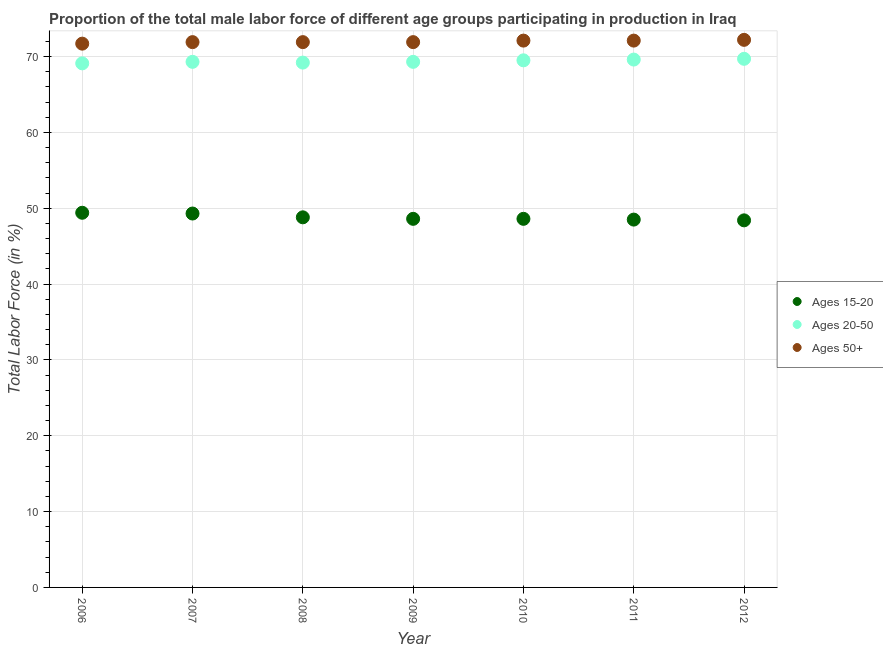How many different coloured dotlines are there?
Ensure brevity in your answer.  3. Is the number of dotlines equal to the number of legend labels?
Offer a terse response. Yes. What is the percentage of male labor force within the age group 15-20 in 2010?
Keep it short and to the point. 48.6. Across all years, what is the maximum percentage of male labor force within the age group 20-50?
Ensure brevity in your answer.  69.7. Across all years, what is the minimum percentage of male labor force above age 50?
Offer a terse response. 71.7. In which year was the percentage of male labor force above age 50 maximum?
Ensure brevity in your answer.  2012. In which year was the percentage of male labor force within the age group 20-50 minimum?
Keep it short and to the point. 2006. What is the total percentage of male labor force above age 50 in the graph?
Give a very brief answer. 503.8. What is the difference between the percentage of male labor force above age 50 in 2007 and that in 2008?
Your answer should be compact. 0. What is the difference between the percentage of male labor force within the age group 20-50 in 2007 and the percentage of male labor force within the age group 15-20 in 2012?
Offer a very short reply. 20.9. What is the average percentage of male labor force above age 50 per year?
Give a very brief answer. 71.97. In the year 2012, what is the difference between the percentage of male labor force within the age group 20-50 and percentage of male labor force within the age group 15-20?
Your answer should be compact. 21.3. What is the ratio of the percentage of male labor force within the age group 20-50 in 2007 to that in 2012?
Give a very brief answer. 0.99. What is the difference between the highest and the second highest percentage of male labor force within the age group 15-20?
Offer a very short reply. 0.1. What is the difference between the highest and the lowest percentage of male labor force within the age group 20-50?
Provide a short and direct response. 0.6. In how many years, is the percentage of male labor force within the age group 20-50 greater than the average percentage of male labor force within the age group 20-50 taken over all years?
Your response must be concise. 3. Is the sum of the percentage of male labor force within the age group 20-50 in 2006 and 2012 greater than the maximum percentage of male labor force within the age group 15-20 across all years?
Provide a short and direct response. Yes. Is it the case that in every year, the sum of the percentage of male labor force within the age group 15-20 and percentage of male labor force within the age group 20-50 is greater than the percentage of male labor force above age 50?
Provide a succinct answer. Yes. Does the percentage of male labor force above age 50 monotonically increase over the years?
Offer a terse response. No. Is the percentage of male labor force above age 50 strictly greater than the percentage of male labor force within the age group 20-50 over the years?
Ensure brevity in your answer.  Yes. How many years are there in the graph?
Ensure brevity in your answer.  7. What is the difference between two consecutive major ticks on the Y-axis?
Your answer should be compact. 10. Are the values on the major ticks of Y-axis written in scientific E-notation?
Your response must be concise. No. Does the graph contain any zero values?
Your response must be concise. No. Does the graph contain grids?
Provide a succinct answer. Yes. What is the title of the graph?
Keep it short and to the point. Proportion of the total male labor force of different age groups participating in production in Iraq. Does "Ages 15-20" appear as one of the legend labels in the graph?
Your answer should be very brief. Yes. What is the label or title of the X-axis?
Keep it short and to the point. Year. What is the label or title of the Y-axis?
Give a very brief answer. Total Labor Force (in %). What is the Total Labor Force (in %) of Ages 15-20 in 2006?
Keep it short and to the point. 49.4. What is the Total Labor Force (in %) of Ages 20-50 in 2006?
Offer a terse response. 69.1. What is the Total Labor Force (in %) of Ages 50+ in 2006?
Ensure brevity in your answer.  71.7. What is the Total Labor Force (in %) of Ages 15-20 in 2007?
Provide a succinct answer. 49.3. What is the Total Labor Force (in %) of Ages 20-50 in 2007?
Offer a very short reply. 69.3. What is the Total Labor Force (in %) of Ages 50+ in 2007?
Give a very brief answer. 71.9. What is the Total Labor Force (in %) in Ages 15-20 in 2008?
Provide a short and direct response. 48.8. What is the Total Labor Force (in %) in Ages 20-50 in 2008?
Your response must be concise. 69.2. What is the Total Labor Force (in %) of Ages 50+ in 2008?
Give a very brief answer. 71.9. What is the Total Labor Force (in %) in Ages 15-20 in 2009?
Give a very brief answer. 48.6. What is the Total Labor Force (in %) in Ages 20-50 in 2009?
Provide a short and direct response. 69.3. What is the Total Labor Force (in %) of Ages 50+ in 2009?
Ensure brevity in your answer.  71.9. What is the Total Labor Force (in %) in Ages 15-20 in 2010?
Your answer should be very brief. 48.6. What is the Total Labor Force (in %) of Ages 20-50 in 2010?
Provide a short and direct response. 69.5. What is the Total Labor Force (in %) in Ages 50+ in 2010?
Keep it short and to the point. 72.1. What is the Total Labor Force (in %) of Ages 15-20 in 2011?
Your answer should be compact. 48.5. What is the Total Labor Force (in %) in Ages 20-50 in 2011?
Make the answer very short. 69.6. What is the Total Labor Force (in %) in Ages 50+ in 2011?
Ensure brevity in your answer.  72.1. What is the Total Labor Force (in %) of Ages 15-20 in 2012?
Ensure brevity in your answer.  48.4. What is the Total Labor Force (in %) in Ages 20-50 in 2012?
Provide a succinct answer. 69.7. What is the Total Labor Force (in %) in Ages 50+ in 2012?
Your answer should be compact. 72.2. Across all years, what is the maximum Total Labor Force (in %) in Ages 15-20?
Offer a very short reply. 49.4. Across all years, what is the maximum Total Labor Force (in %) in Ages 20-50?
Give a very brief answer. 69.7. Across all years, what is the maximum Total Labor Force (in %) in Ages 50+?
Offer a very short reply. 72.2. Across all years, what is the minimum Total Labor Force (in %) in Ages 15-20?
Ensure brevity in your answer.  48.4. Across all years, what is the minimum Total Labor Force (in %) of Ages 20-50?
Offer a terse response. 69.1. Across all years, what is the minimum Total Labor Force (in %) in Ages 50+?
Your answer should be very brief. 71.7. What is the total Total Labor Force (in %) in Ages 15-20 in the graph?
Your answer should be very brief. 341.6. What is the total Total Labor Force (in %) in Ages 20-50 in the graph?
Provide a succinct answer. 485.7. What is the total Total Labor Force (in %) of Ages 50+ in the graph?
Your response must be concise. 503.8. What is the difference between the Total Labor Force (in %) of Ages 15-20 in 2006 and that in 2007?
Ensure brevity in your answer.  0.1. What is the difference between the Total Labor Force (in %) of Ages 20-50 in 2006 and that in 2007?
Keep it short and to the point. -0.2. What is the difference between the Total Labor Force (in %) in Ages 15-20 in 2006 and that in 2008?
Keep it short and to the point. 0.6. What is the difference between the Total Labor Force (in %) of Ages 20-50 in 2006 and that in 2008?
Offer a very short reply. -0.1. What is the difference between the Total Labor Force (in %) in Ages 50+ in 2006 and that in 2008?
Your answer should be very brief. -0.2. What is the difference between the Total Labor Force (in %) in Ages 15-20 in 2006 and that in 2010?
Keep it short and to the point. 0.8. What is the difference between the Total Labor Force (in %) in Ages 20-50 in 2006 and that in 2010?
Give a very brief answer. -0.4. What is the difference between the Total Labor Force (in %) of Ages 50+ in 2006 and that in 2012?
Keep it short and to the point. -0.5. What is the difference between the Total Labor Force (in %) in Ages 15-20 in 2007 and that in 2008?
Offer a very short reply. 0.5. What is the difference between the Total Labor Force (in %) in Ages 20-50 in 2007 and that in 2008?
Your answer should be compact. 0.1. What is the difference between the Total Labor Force (in %) of Ages 15-20 in 2007 and that in 2009?
Your response must be concise. 0.7. What is the difference between the Total Labor Force (in %) of Ages 20-50 in 2007 and that in 2009?
Offer a very short reply. 0. What is the difference between the Total Labor Force (in %) in Ages 50+ in 2007 and that in 2009?
Your response must be concise. 0. What is the difference between the Total Labor Force (in %) in Ages 50+ in 2007 and that in 2010?
Keep it short and to the point. -0.2. What is the difference between the Total Labor Force (in %) in Ages 15-20 in 2007 and that in 2011?
Make the answer very short. 0.8. What is the difference between the Total Labor Force (in %) of Ages 15-20 in 2007 and that in 2012?
Your response must be concise. 0.9. What is the difference between the Total Labor Force (in %) in Ages 50+ in 2007 and that in 2012?
Provide a short and direct response. -0.3. What is the difference between the Total Labor Force (in %) of Ages 15-20 in 2008 and that in 2009?
Your response must be concise. 0.2. What is the difference between the Total Labor Force (in %) of Ages 20-50 in 2008 and that in 2009?
Provide a succinct answer. -0.1. What is the difference between the Total Labor Force (in %) in Ages 20-50 in 2008 and that in 2010?
Make the answer very short. -0.3. What is the difference between the Total Labor Force (in %) of Ages 50+ in 2008 and that in 2010?
Offer a very short reply. -0.2. What is the difference between the Total Labor Force (in %) of Ages 15-20 in 2008 and that in 2011?
Ensure brevity in your answer.  0.3. What is the difference between the Total Labor Force (in %) of Ages 20-50 in 2008 and that in 2011?
Offer a very short reply. -0.4. What is the difference between the Total Labor Force (in %) in Ages 50+ in 2008 and that in 2011?
Offer a terse response. -0.2. What is the difference between the Total Labor Force (in %) in Ages 15-20 in 2008 and that in 2012?
Provide a short and direct response. 0.4. What is the difference between the Total Labor Force (in %) in Ages 20-50 in 2008 and that in 2012?
Your answer should be compact. -0.5. What is the difference between the Total Labor Force (in %) in Ages 15-20 in 2009 and that in 2011?
Your response must be concise. 0.1. What is the difference between the Total Labor Force (in %) of Ages 50+ in 2009 and that in 2011?
Make the answer very short. -0.2. What is the difference between the Total Labor Force (in %) of Ages 15-20 in 2009 and that in 2012?
Give a very brief answer. 0.2. What is the difference between the Total Labor Force (in %) in Ages 20-50 in 2009 and that in 2012?
Provide a short and direct response. -0.4. What is the difference between the Total Labor Force (in %) in Ages 50+ in 2010 and that in 2011?
Ensure brevity in your answer.  0. What is the difference between the Total Labor Force (in %) of Ages 20-50 in 2010 and that in 2012?
Keep it short and to the point. -0.2. What is the difference between the Total Labor Force (in %) of Ages 50+ in 2010 and that in 2012?
Provide a succinct answer. -0.1. What is the difference between the Total Labor Force (in %) in Ages 50+ in 2011 and that in 2012?
Make the answer very short. -0.1. What is the difference between the Total Labor Force (in %) in Ages 15-20 in 2006 and the Total Labor Force (in %) in Ages 20-50 in 2007?
Ensure brevity in your answer.  -19.9. What is the difference between the Total Labor Force (in %) in Ages 15-20 in 2006 and the Total Labor Force (in %) in Ages 50+ in 2007?
Ensure brevity in your answer.  -22.5. What is the difference between the Total Labor Force (in %) in Ages 20-50 in 2006 and the Total Labor Force (in %) in Ages 50+ in 2007?
Provide a succinct answer. -2.8. What is the difference between the Total Labor Force (in %) in Ages 15-20 in 2006 and the Total Labor Force (in %) in Ages 20-50 in 2008?
Your answer should be compact. -19.8. What is the difference between the Total Labor Force (in %) in Ages 15-20 in 2006 and the Total Labor Force (in %) in Ages 50+ in 2008?
Give a very brief answer. -22.5. What is the difference between the Total Labor Force (in %) of Ages 15-20 in 2006 and the Total Labor Force (in %) of Ages 20-50 in 2009?
Keep it short and to the point. -19.9. What is the difference between the Total Labor Force (in %) in Ages 15-20 in 2006 and the Total Labor Force (in %) in Ages 50+ in 2009?
Give a very brief answer. -22.5. What is the difference between the Total Labor Force (in %) of Ages 20-50 in 2006 and the Total Labor Force (in %) of Ages 50+ in 2009?
Your answer should be compact. -2.8. What is the difference between the Total Labor Force (in %) of Ages 15-20 in 2006 and the Total Labor Force (in %) of Ages 20-50 in 2010?
Provide a short and direct response. -20.1. What is the difference between the Total Labor Force (in %) of Ages 15-20 in 2006 and the Total Labor Force (in %) of Ages 50+ in 2010?
Provide a short and direct response. -22.7. What is the difference between the Total Labor Force (in %) of Ages 20-50 in 2006 and the Total Labor Force (in %) of Ages 50+ in 2010?
Provide a succinct answer. -3. What is the difference between the Total Labor Force (in %) of Ages 15-20 in 2006 and the Total Labor Force (in %) of Ages 20-50 in 2011?
Offer a very short reply. -20.2. What is the difference between the Total Labor Force (in %) of Ages 15-20 in 2006 and the Total Labor Force (in %) of Ages 50+ in 2011?
Ensure brevity in your answer.  -22.7. What is the difference between the Total Labor Force (in %) in Ages 15-20 in 2006 and the Total Labor Force (in %) in Ages 20-50 in 2012?
Your answer should be compact. -20.3. What is the difference between the Total Labor Force (in %) of Ages 15-20 in 2006 and the Total Labor Force (in %) of Ages 50+ in 2012?
Ensure brevity in your answer.  -22.8. What is the difference between the Total Labor Force (in %) of Ages 20-50 in 2006 and the Total Labor Force (in %) of Ages 50+ in 2012?
Offer a very short reply. -3.1. What is the difference between the Total Labor Force (in %) in Ages 15-20 in 2007 and the Total Labor Force (in %) in Ages 20-50 in 2008?
Offer a terse response. -19.9. What is the difference between the Total Labor Force (in %) of Ages 15-20 in 2007 and the Total Labor Force (in %) of Ages 50+ in 2008?
Ensure brevity in your answer.  -22.6. What is the difference between the Total Labor Force (in %) of Ages 20-50 in 2007 and the Total Labor Force (in %) of Ages 50+ in 2008?
Your answer should be very brief. -2.6. What is the difference between the Total Labor Force (in %) of Ages 15-20 in 2007 and the Total Labor Force (in %) of Ages 20-50 in 2009?
Your answer should be compact. -20. What is the difference between the Total Labor Force (in %) of Ages 15-20 in 2007 and the Total Labor Force (in %) of Ages 50+ in 2009?
Provide a succinct answer. -22.6. What is the difference between the Total Labor Force (in %) in Ages 15-20 in 2007 and the Total Labor Force (in %) in Ages 20-50 in 2010?
Ensure brevity in your answer.  -20.2. What is the difference between the Total Labor Force (in %) in Ages 15-20 in 2007 and the Total Labor Force (in %) in Ages 50+ in 2010?
Offer a very short reply. -22.8. What is the difference between the Total Labor Force (in %) of Ages 15-20 in 2007 and the Total Labor Force (in %) of Ages 20-50 in 2011?
Keep it short and to the point. -20.3. What is the difference between the Total Labor Force (in %) in Ages 15-20 in 2007 and the Total Labor Force (in %) in Ages 50+ in 2011?
Offer a terse response. -22.8. What is the difference between the Total Labor Force (in %) in Ages 15-20 in 2007 and the Total Labor Force (in %) in Ages 20-50 in 2012?
Offer a very short reply. -20.4. What is the difference between the Total Labor Force (in %) of Ages 15-20 in 2007 and the Total Labor Force (in %) of Ages 50+ in 2012?
Make the answer very short. -22.9. What is the difference between the Total Labor Force (in %) of Ages 15-20 in 2008 and the Total Labor Force (in %) of Ages 20-50 in 2009?
Your answer should be very brief. -20.5. What is the difference between the Total Labor Force (in %) in Ages 15-20 in 2008 and the Total Labor Force (in %) in Ages 50+ in 2009?
Your answer should be very brief. -23.1. What is the difference between the Total Labor Force (in %) in Ages 20-50 in 2008 and the Total Labor Force (in %) in Ages 50+ in 2009?
Offer a very short reply. -2.7. What is the difference between the Total Labor Force (in %) of Ages 15-20 in 2008 and the Total Labor Force (in %) of Ages 20-50 in 2010?
Ensure brevity in your answer.  -20.7. What is the difference between the Total Labor Force (in %) of Ages 15-20 in 2008 and the Total Labor Force (in %) of Ages 50+ in 2010?
Your answer should be compact. -23.3. What is the difference between the Total Labor Force (in %) of Ages 15-20 in 2008 and the Total Labor Force (in %) of Ages 20-50 in 2011?
Offer a very short reply. -20.8. What is the difference between the Total Labor Force (in %) of Ages 15-20 in 2008 and the Total Labor Force (in %) of Ages 50+ in 2011?
Offer a terse response. -23.3. What is the difference between the Total Labor Force (in %) in Ages 20-50 in 2008 and the Total Labor Force (in %) in Ages 50+ in 2011?
Your response must be concise. -2.9. What is the difference between the Total Labor Force (in %) of Ages 15-20 in 2008 and the Total Labor Force (in %) of Ages 20-50 in 2012?
Your response must be concise. -20.9. What is the difference between the Total Labor Force (in %) in Ages 15-20 in 2008 and the Total Labor Force (in %) in Ages 50+ in 2012?
Your response must be concise. -23.4. What is the difference between the Total Labor Force (in %) of Ages 15-20 in 2009 and the Total Labor Force (in %) of Ages 20-50 in 2010?
Ensure brevity in your answer.  -20.9. What is the difference between the Total Labor Force (in %) of Ages 15-20 in 2009 and the Total Labor Force (in %) of Ages 50+ in 2010?
Your answer should be compact. -23.5. What is the difference between the Total Labor Force (in %) in Ages 15-20 in 2009 and the Total Labor Force (in %) in Ages 20-50 in 2011?
Give a very brief answer. -21. What is the difference between the Total Labor Force (in %) of Ages 15-20 in 2009 and the Total Labor Force (in %) of Ages 50+ in 2011?
Keep it short and to the point. -23.5. What is the difference between the Total Labor Force (in %) of Ages 20-50 in 2009 and the Total Labor Force (in %) of Ages 50+ in 2011?
Keep it short and to the point. -2.8. What is the difference between the Total Labor Force (in %) of Ages 15-20 in 2009 and the Total Labor Force (in %) of Ages 20-50 in 2012?
Your answer should be very brief. -21.1. What is the difference between the Total Labor Force (in %) of Ages 15-20 in 2009 and the Total Labor Force (in %) of Ages 50+ in 2012?
Your response must be concise. -23.6. What is the difference between the Total Labor Force (in %) of Ages 15-20 in 2010 and the Total Labor Force (in %) of Ages 20-50 in 2011?
Provide a short and direct response. -21. What is the difference between the Total Labor Force (in %) in Ages 15-20 in 2010 and the Total Labor Force (in %) in Ages 50+ in 2011?
Your response must be concise. -23.5. What is the difference between the Total Labor Force (in %) in Ages 20-50 in 2010 and the Total Labor Force (in %) in Ages 50+ in 2011?
Provide a succinct answer. -2.6. What is the difference between the Total Labor Force (in %) of Ages 15-20 in 2010 and the Total Labor Force (in %) of Ages 20-50 in 2012?
Provide a short and direct response. -21.1. What is the difference between the Total Labor Force (in %) in Ages 15-20 in 2010 and the Total Labor Force (in %) in Ages 50+ in 2012?
Your answer should be very brief. -23.6. What is the difference between the Total Labor Force (in %) in Ages 15-20 in 2011 and the Total Labor Force (in %) in Ages 20-50 in 2012?
Offer a very short reply. -21.2. What is the difference between the Total Labor Force (in %) in Ages 15-20 in 2011 and the Total Labor Force (in %) in Ages 50+ in 2012?
Your response must be concise. -23.7. What is the difference between the Total Labor Force (in %) of Ages 20-50 in 2011 and the Total Labor Force (in %) of Ages 50+ in 2012?
Make the answer very short. -2.6. What is the average Total Labor Force (in %) in Ages 15-20 per year?
Your answer should be very brief. 48.8. What is the average Total Labor Force (in %) in Ages 20-50 per year?
Keep it short and to the point. 69.39. What is the average Total Labor Force (in %) in Ages 50+ per year?
Provide a succinct answer. 71.97. In the year 2006, what is the difference between the Total Labor Force (in %) of Ages 15-20 and Total Labor Force (in %) of Ages 20-50?
Your answer should be very brief. -19.7. In the year 2006, what is the difference between the Total Labor Force (in %) in Ages 15-20 and Total Labor Force (in %) in Ages 50+?
Provide a short and direct response. -22.3. In the year 2006, what is the difference between the Total Labor Force (in %) in Ages 20-50 and Total Labor Force (in %) in Ages 50+?
Your response must be concise. -2.6. In the year 2007, what is the difference between the Total Labor Force (in %) of Ages 15-20 and Total Labor Force (in %) of Ages 50+?
Ensure brevity in your answer.  -22.6. In the year 2008, what is the difference between the Total Labor Force (in %) of Ages 15-20 and Total Labor Force (in %) of Ages 20-50?
Your response must be concise. -20.4. In the year 2008, what is the difference between the Total Labor Force (in %) in Ages 15-20 and Total Labor Force (in %) in Ages 50+?
Keep it short and to the point. -23.1. In the year 2008, what is the difference between the Total Labor Force (in %) of Ages 20-50 and Total Labor Force (in %) of Ages 50+?
Make the answer very short. -2.7. In the year 2009, what is the difference between the Total Labor Force (in %) of Ages 15-20 and Total Labor Force (in %) of Ages 20-50?
Provide a succinct answer. -20.7. In the year 2009, what is the difference between the Total Labor Force (in %) in Ages 15-20 and Total Labor Force (in %) in Ages 50+?
Give a very brief answer. -23.3. In the year 2010, what is the difference between the Total Labor Force (in %) in Ages 15-20 and Total Labor Force (in %) in Ages 20-50?
Provide a short and direct response. -20.9. In the year 2010, what is the difference between the Total Labor Force (in %) of Ages 15-20 and Total Labor Force (in %) of Ages 50+?
Make the answer very short. -23.5. In the year 2011, what is the difference between the Total Labor Force (in %) of Ages 15-20 and Total Labor Force (in %) of Ages 20-50?
Offer a terse response. -21.1. In the year 2011, what is the difference between the Total Labor Force (in %) of Ages 15-20 and Total Labor Force (in %) of Ages 50+?
Provide a short and direct response. -23.6. In the year 2012, what is the difference between the Total Labor Force (in %) in Ages 15-20 and Total Labor Force (in %) in Ages 20-50?
Offer a terse response. -21.3. In the year 2012, what is the difference between the Total Labor Force (in %) in Ages 15-20 and Total Labor Force (in %) in Ages 50+?
Your response must be concise. -23.8. In the year 2012, what is the difference between the Total Labor Force (in %) of Ages 20-50 and Total Labor Force (in %) of Ages 50+?
Ensure brevity in your answer.  -2.5. What is the ratio of the Total Labor Force (in %) of Ages 50+ in 2006 to that in 2007?
Your answer should be compact. 1. What is the ratio of the Total Labor Force (in %) of Ages 15-20 in 2006 to that in 2008?
Offer a terse response. 1.01. What is the ratio of the Total Labor Force (in %) in Ages 15-20 in 2006 to that in 2009?
Provide a short and direct response. 1.02. What is the ratio of the Total Labor Force (in %) in Ages 15-20 in 2006 to that in 2010?
Provide a short and direct response. 1.02. What is the ratio of the Total Labor Force (in %) in Ages 20-50 in 2006 to that in 2010?
Ensure brevity in your answer.  0.99. What is the ratio of the Total Labor Force (in %) in Ages 15-20 in 2006 to that in 2011?
Keep it short and to the point. 1.02. What is the ratio of the Total Labor Force (in %) in Ages 15-20 in 2006 to that in 2012?
Ensure brevity in your answer.  1.02. What is the ratio of the Total Labor Force (in %) of Ages 50+ in 2006 to that in 2012?
Provide a succinct answer. 0.99. What is the ratio of the Total Labor Force (in %) of Ages 15-20 in 2007 to that in 2008?
Offer a terse response. 1.01. What is the ratio of the Total Labor Force (in %) of Ages 15-20 in 2007 to that in 2009?
Offer a very short reply. 1.01. What is the ratio of the Total Labor Force (in %) of Ages 50+ in 2007 to that in 2009?
Ensure brevity in your answer.  1. What is the ratio of the Total Labor Force (in %) in Ages 15-20 in 2007 to that in 2010?
Provide a short and direct response. 1.01. What is the ratio of the Total Labor Force (in %) in Ages 50+ in 2007 to that in 2010?
Keep it short and to the point. 1. What is the ratio of the Total Labor Force (in %) in Ages 15-20 in 2007 to that in 2011?
Provide a succinct answer. 1.02. What is the ratio of the Total Labor Force (in %) of Ages 20-50 in 2007 to that in 2011?
Provide a succinct answer. 1. What is the ratio of the Total Labor Force (in %) of Ages 15-20 in 2007 to that in 2012?
Your answer should be compact. 1.02. What is the ratio of the Total Labor Force (in %) of Ages 20-50 in 2007 to that in 2012?
Your answer should be very brief. 0.99. What is the ratio of the Total Labor Force (in %) in Ages 50+ in 2007 to that in 2012?
Ensure brevity in your answer.  1. What is the ratio of the Total Labor Force (in %) in Ages 15-20 in 2008 to that in 2009?
Make the answer very short. 1. What is the ratio of the Total Labor Force (in %) of Ages 50+ in 2008 to that in 2009?
Give a very brief answer. 1. What is the ratio of the Total Labor Force (in %) of Ages 15-20 in 2008 to that in 2010?
Offer a very short reply. 1. What is the ratio of the Total Labor Force (in %) of Ages 20-50 in 2008 to that in 2010?
Your answer should be very brief. 1. What is the ratio of the Total Labor Force (in %) in Ages 50+ in 2008 to that in 2010?
Your answer should be compact. 1. What is the ratio of the Total Labor Force (in %) of Ages 15-20 in 2008 to that in 2011?
Provide a short and direct response. 1.01. What is the ratio of the Total Labor Force (in %) of Ages 20-50 in 2008 to that in 2011?
Make the answer very short. 0.99. What is the ratio of the Total Labor Force (in %) in Ages 50+ in 2008 to that in 2011?
Keep it short and to the point. 1. What is the ratio of the Total Labor Force (in %) of Ages 15-20 in 2008 to that in 2012?
Provide a succinct answer. 1.01. What is the ratio of the Total Labor Force (in %) in Ages 20-50 in 2008 to that in 2012?
Offer a very short reply. 0.99. What is the ratio of the Total Labor Force (in %) of Ages 20-50 in 2009 to that in 2010?
Your answer should be compact. 1. What is the ratio of the Total Labor Force (in %) in Ages 50+ in 2009 to that in 2010?
Offer a terse response. 1. What is the ratio of the Total Labor Force (in %) in Ages 50+ in 2009 to that in 2012?
Make the answer very short. 1. What is the ratio of the Total Labor Force (in %) in Ages 15-20 in 2010 to that in 2012?
Your answer should be compact. 1. What is the ratio of the Total Labor Force (in %) in Ages 20-50 in 2010 to that in 2012?
Your answer should be compact. 1. What is the ratio of the Total Labor Force (in %) of Ages 20-50 in 2011 to that in 2012?
Make the answer very short. 1. What is the ratio of the Total Labor Force (in %) in Ages 50+ in 2011 to that in 2012?
Keep it short and to the point. 1. What is the difference between the highest and the second highest Total Labor Force (in %) of Ages 15-20?
Provide a short and direct response. 0.1. What is the difference between the highest and the second highest Total Labor Force (in %) in Ages 20-50?
Your response must be concise. 0.1. What is the difference between the highest and the second highest Total Labor Force (in %) of Ages 50+?
Offer a very short reply. 0.1. What is the difference between the highest and the lowest Total Labor Force (in %) of Ages 20-50?
Offer a very short reply. 0.6. What is the difference between the highest and the lowest Total Labor Force (in %) of Ages 50+?
Ensure brevity in your answer.  0.5. 